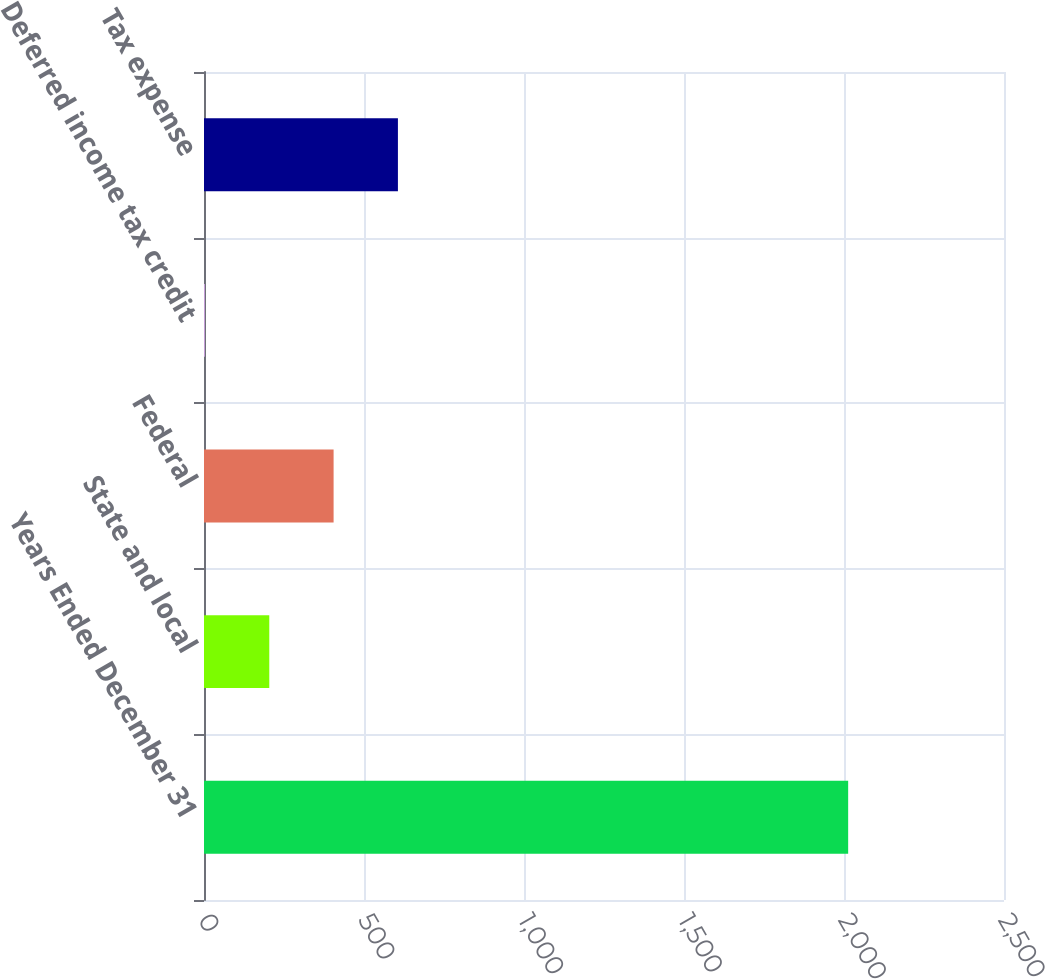<chart> <loc_0><loc_0><loc_500><loc_500><bar_chart><fcel>Years Ended December 31<fcel>State and local<fcel>Federal<fcel>Deferred income tax credit<fcel>Tax expense<nl><fcel>2013<fcel>204<fcel>405<fcel>3<fcel>606<nl></chart> 